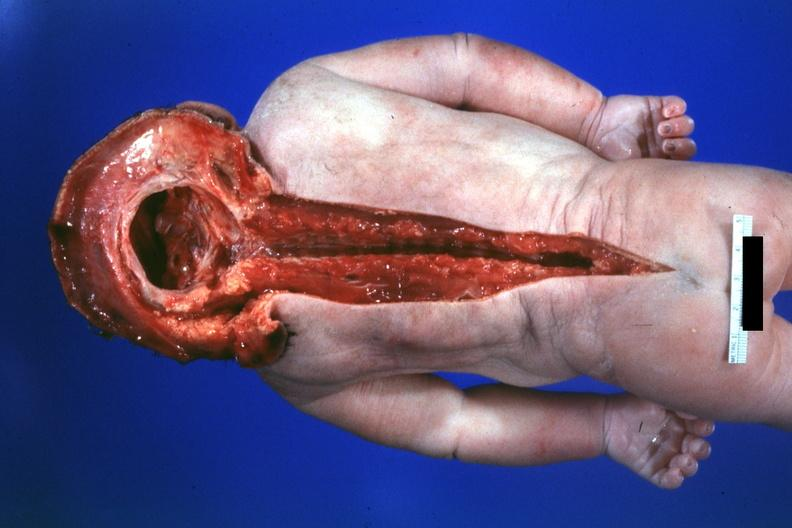s brain present?
Answer the question using a single word or phrase. Yes 